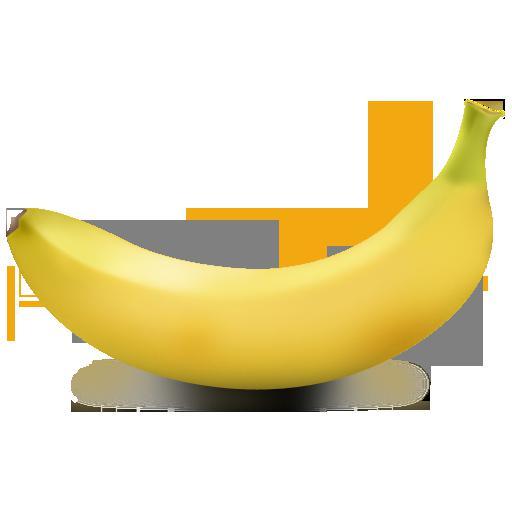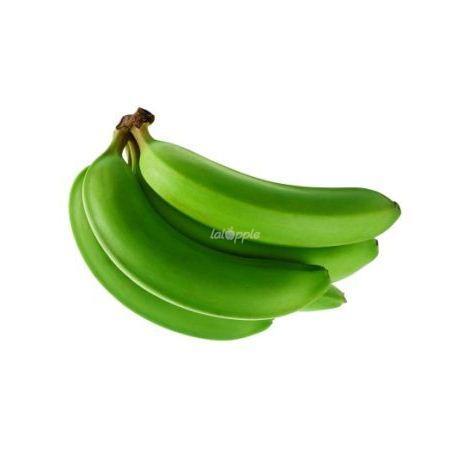The first image is the image on the left, the second image is the image on the right. Analyze the images presented: Is the assertion "One of the images is exactly three green bananas, and this particular bunch is not connected." valid? Answer yes or no. No. 